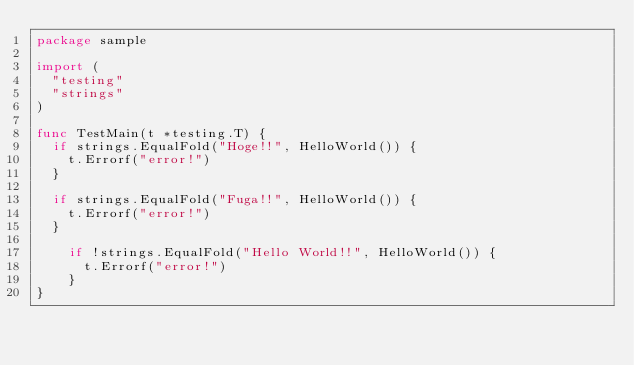<code> <loc_0><loc_0><loc_500><loc_500><_Go_>package sample

import (
  "testing"
  "strings"
)

func TestMain(t *testing.T) {
	if strings.EqualFold("Hoge!!", HelloWorld()) {
		t.Errorf("error!") 
	}

	if strings.EqualFold("Fuga!!", HelloWorld()) {
		t.Errorf("error!") 
	}

  	if !strings.EqualFold("Hello World!!", HelloWorld()) {
    	t.Errorf("error!") 
  	}
}</code> 